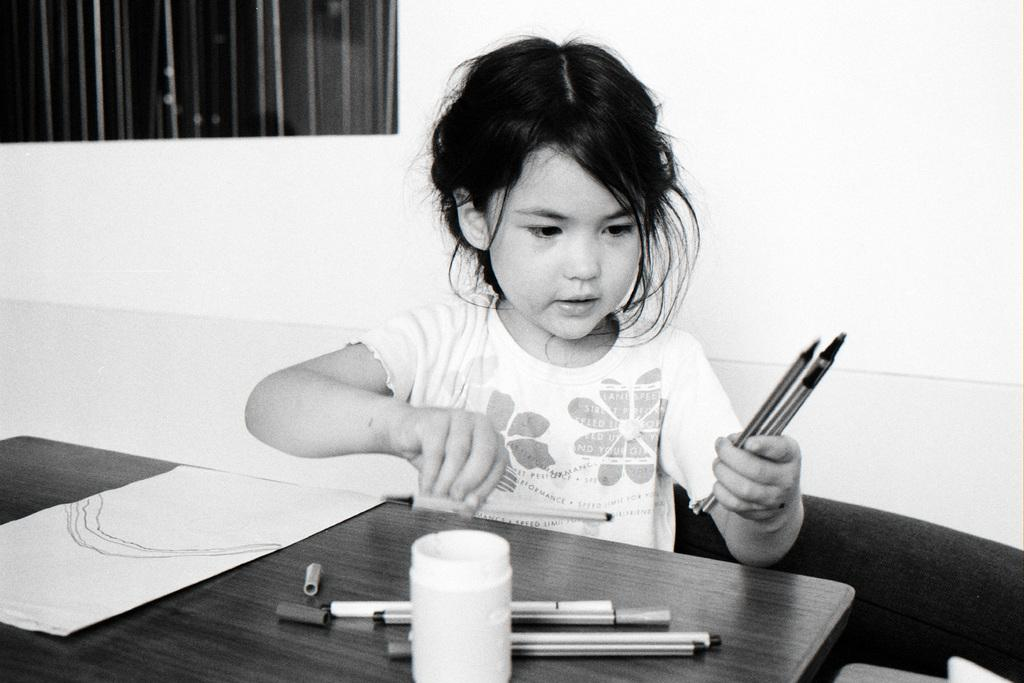Who is the main subject in the image? There is a girl in the image. What is the girl doing in the image? The girl is sitting in front of a table. What is the girl holding in her hand? The girl is holding pens in her hand. What is on the table in front of the girl? There is a paper and a box on the table. Are there any other writing instruments visible on the table? Yes, there are pens on the table. What can be seen in the background of the image? There is a wall in the background of the image. How does the wind affect the girl's hair in the image? There is no wind present in the image, so it does not affect the girl's hair. Is there a beggar visible in the image? No, there is no beggar present in the image. 